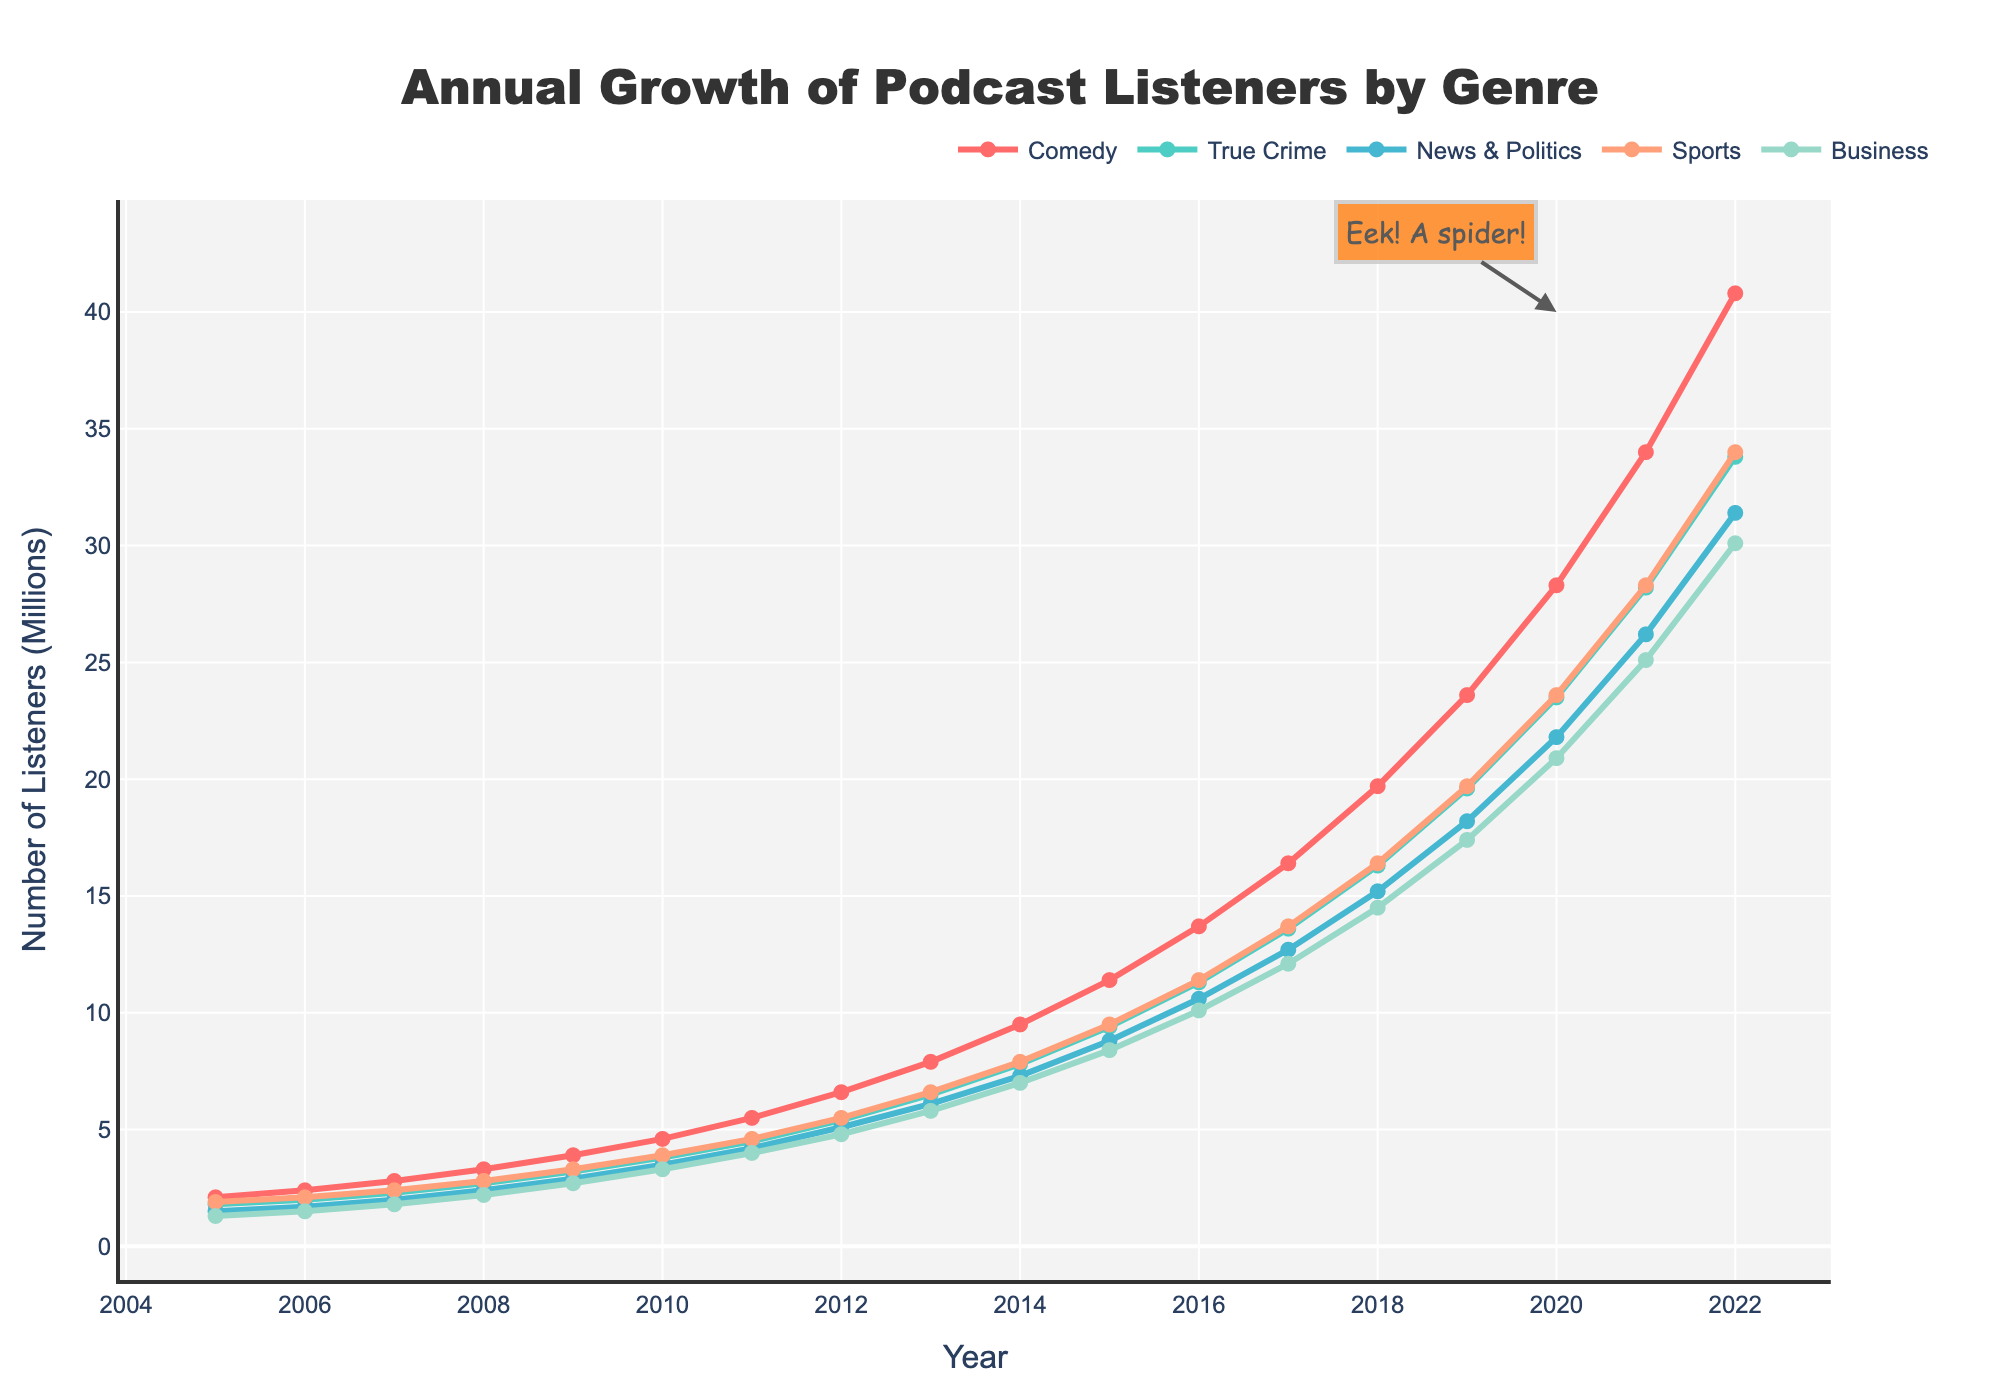what is the highest number of comedy podcast listeners in the given years? Reviewing the data for comedy genres from 2005 to 2022, the highest number of listeners is found in 2022, which is 40.8 million.
Answer: 40.8 million what's the difference in the number of comedy podcast listeners between 2010 and 2020? In 2010, the number of comedy podcast listeners was 4.6 million, and in 2020, it was 28.3 million. Subtracting these gives: 28.3 - 4.6 = 23.7 million.
Answer: 23.7 million which genre had the fastest growth in podcast listeners between 2005 and 2022? To find the fastest growth, check the increase in listeners from 2005 to 2022 for each genre. Comedy increased from 2.1 to 40.8 million (38.7 million), True Crime from 1.8 to 33.8 million (32 million), News & Politics from 1.5 to 31.4 million (29.9 million), Sports from 1.9 to 34 million (32.1 million), Business from 1.3 to 30.1 million (28.8 million). Comedy has the highest increase (38.7 million).
Answer: Comedy in which year did comedy podcast listeners surpass 10 million? By examining the data, comedy listeners reached 11.4 million in 2015. Thus, 2015 is the year when the number exceeded 10 million.
Answer: 2015 which genre had fewer listeners in 2022, business or News & Politics? In 2022, News & Politics had 31.4 million listeners, whereas Business had 30.1 million. Since 30.1 million is less than 31.4 million, Business had fewer listeners.
Answer: Business what is the sum of comedy and true crime podcast listeners in 2018? In 2018, comedy had 19.7 million listeners and True Crime had 16.3 million. Adding these: 19.7 + 16.3 = 36 million listeners.
Answer: 36 million which genre experienced a larger increase in listeners between 2010 and 2015, sports or business? Sports went from 3.9 million in 2010 to 9.5 million in 2015, an increase of 5.6 million. Business increased from 3.3 million in 2010 to 8.4 million in 2015, an increase of 5.1 million. Therefore, Sports had a larger increase.
Answer: Sports in visually comparing the trends, which genre has the steepest line overall, indicating the most rapid growth? Visually inspecting the lines on the plot, the line for Comedy is the steepest, indicating it has the most rapid growth compared to other genres.
Answer: Comedy how much did the number of comedy podcast listeners grow from 2005 to 2009? From 2005 to 2009, comedy listeners grew from 2.1 million to 3.9 million. The growth is: 3.9 - 2.1 = 1.8 million.
Answer: 1.8 million 